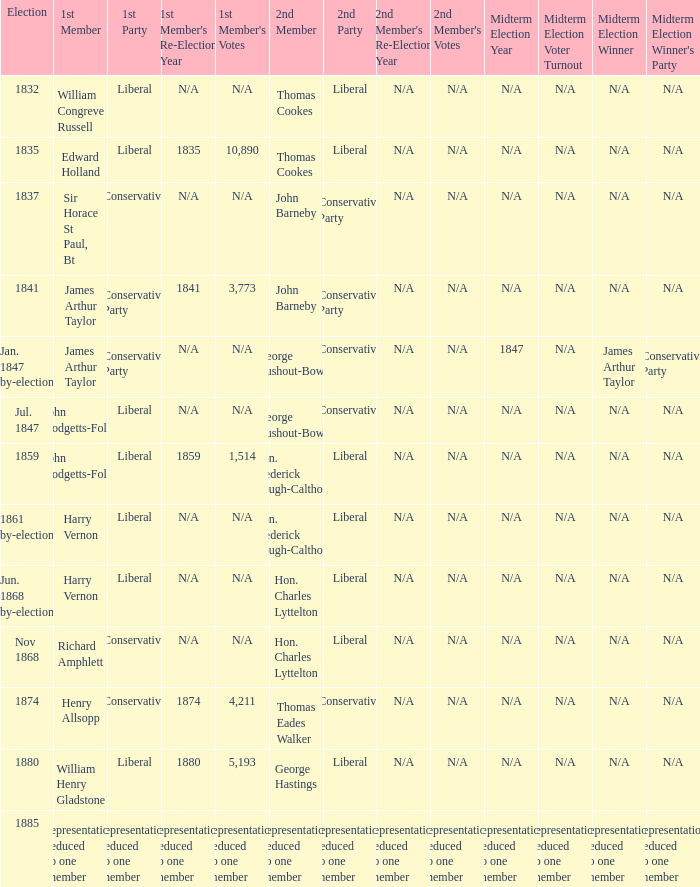What was the 2nd Party that had the 2nd Member John Barneby, when the 1st Party was Conservative? Conservative Party. Could you parse the entire table as a dict? {'header': ['Election', '1st Member', '1st Party', "1st Member's Re-Election Year", "1st Member's Votes", '2nd Member', '2nd Party', "2nd Member's Re-Election Year", "2nd Member's Votes", 'Midterm Election Year', 'Midterm Election Voter Turnout', 'Midterm Election Winner', "Midterm Election Winner's Party"], 'rows': [['1832', 'William Congreve Russell', 'Liberal', 'N/A', 'N/A', 'Thomas Cookes', 'Liberal', 'N/A', 'N/A', 'N/A', 'N/A', 'N/A', 'N/A'], ['1835', 'Edward Holland', 'Liberal', '1835', '10,890', 'Thomas Cookes', 'Liberal', 'N/A', 'N/A', 'N/A', 'N/A', 'N/A', 'N/A'], ['1837', 'Sir Horace St Paul, Bt', 'Conservative', 'N/A', 'N/A', 'John Barneby', 'Conservative Party', 'N/A', 'N/A', 'N/A', 'N/A', 'N/A', 'N/A'], ['1841', 'James Arthur Taylor', 'Conservative Party', '1841', '3,773', 'John Barneby', 'Conservative Party', 'N/A', 'N/A', 'N/A', 'N/A', 'N/A', 'N/A'], ['Jan. 1847 by-election', 'James Arthur Taylor', 'Conservative Party', 'N/A', 'N/A', 'George Rushout-Bowes', 'Conservative', 'N/A', 'N/A', '1847', 'N/A', 'James Arthur Taylor', 'Conservative Party'], ['Jul. 1847', 'John Hodgetts-Foley', 'Liberal', 'N/A', 'N/A', 'George Rushout-Bowes', 'Conservative', 'N/A', 'N/A', 'N/A', 'N/A', 'N/A', 'N/A'], ['1859', 'John Hodgetts-Foley', 'Liberal', '1859', '1,514', 'Hon. Frederick Gough-Calthorpe', 'Liberal', 'N/A', 'N/A', 'N/A', 'N/A', 'N/A', 'N/A'], ['1861 by-election', 'Harry Vernon', 'Liberal', 'N/A', 'N/A', 'Hon. Frederick Gough-Calthorpe', 'Liberal', 'N/A', 'N/A', 'N/A', 'N/A', 'N/A', 'N/A'], ['Jun. 1868 by-election', 'Harry Vernon', 'Liberal', 'N/A', 'N/A', 'Hon. Charles Lyttelton', 'Liberal', 'N/A', 'N/A', 'N/A', 'N/A', 'N/A', 'N/A'], ['Nov 1868', 'Richard Amphlett', 'Conservative', 'N/A', 'N/A', 'Hon. Charles Lyttelton', 'Liberal', 'N/A', 'N/A', 'N/A', 'N/A', 'N/A', 'N/A'], ['1874', 'Henry Allsopp', 'Conservative', '1874', '4,211', 'Thomas Eades Walker', 'Conservative', 'N/A', 'N/A', 'N/A', 'N/A', 'N/A', 'N/A'], ['1880', 'William Henry Gladstone', 'Liberal', '1880', '5,193', 'George Hastings', 'Liberal', 'N/A', 'N/A', 'N/A', 'N/A', 'N/A', 'N/A'], ['1885', 'representation reduced to one member', 'representation reduced to one member', 'representation reduced to one member', 'representation reduced to one member', 'representation reduced to one member', 'representation reduced to one member', 'representation reduced to one member', 'representation reduced to one member', 'representation reduced to one member', 'representation reduced to one member', 'representation reduced to one member', 'representation reduced to one member']]} 